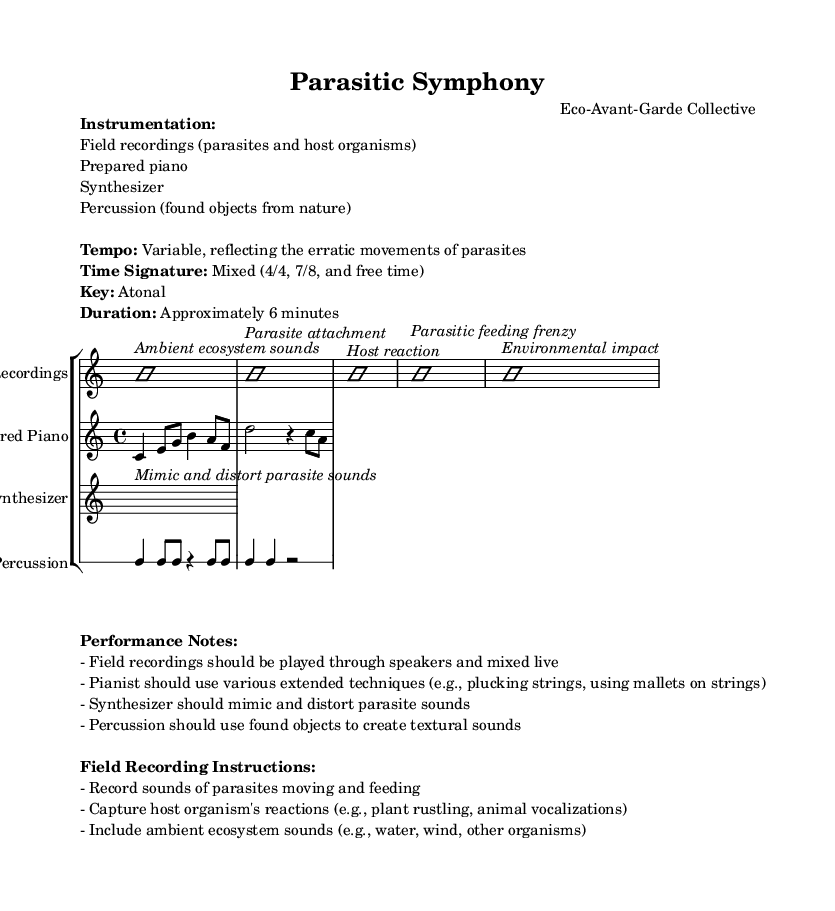What is the title of the composition? The title, as indicated in the header, is "Parasitic Symphony."
Answer: Parasitic Symphony What is the tempo of the piece? The tempo is described as variable, which means it changes throughout the piece to reflect the erratic movements of parasites.
Answer: Variable What are the primary instruments used in this composition? The instrumentation lists field recordings, prepared piano, synthesizer, and percussion as the primary instruments.
Answer: Field recordings, prepared piano, synthesizer, percussion What is the time signature of the prepared piano? The prepared piano begins with a time signature of 4/4, as indicated at the start of its staff.
Answer: 4/4 How long is the performance intended to last? The duration of the piece is specified as approximately 6 minutes, providing a clear expectation for the performance length.
Answer: Approximately 6 minutes Explain the significance of using field recordings in this experimental composition. The field recordings play a crucial role in the piece, as they represent the sounds of parasites and host organisms, blending natural and musical elements to create an immersive experience.
Answer: To blend natural and musical elements What does the synthesizer mimic in this composition? The synthesizer is noted to mimic and distort parasite sounds, adding to the overall texture and thematic emphasis of parasitism in the work.
Answer: Parasite sounds 